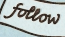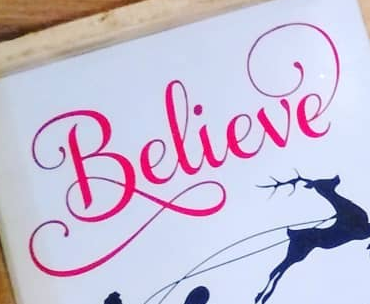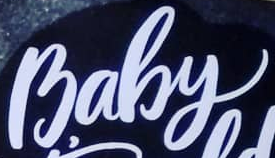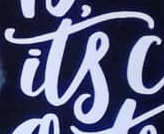What words can you see in these images in sequence, separated by a semicolon? follow; Believe; Baby; its 